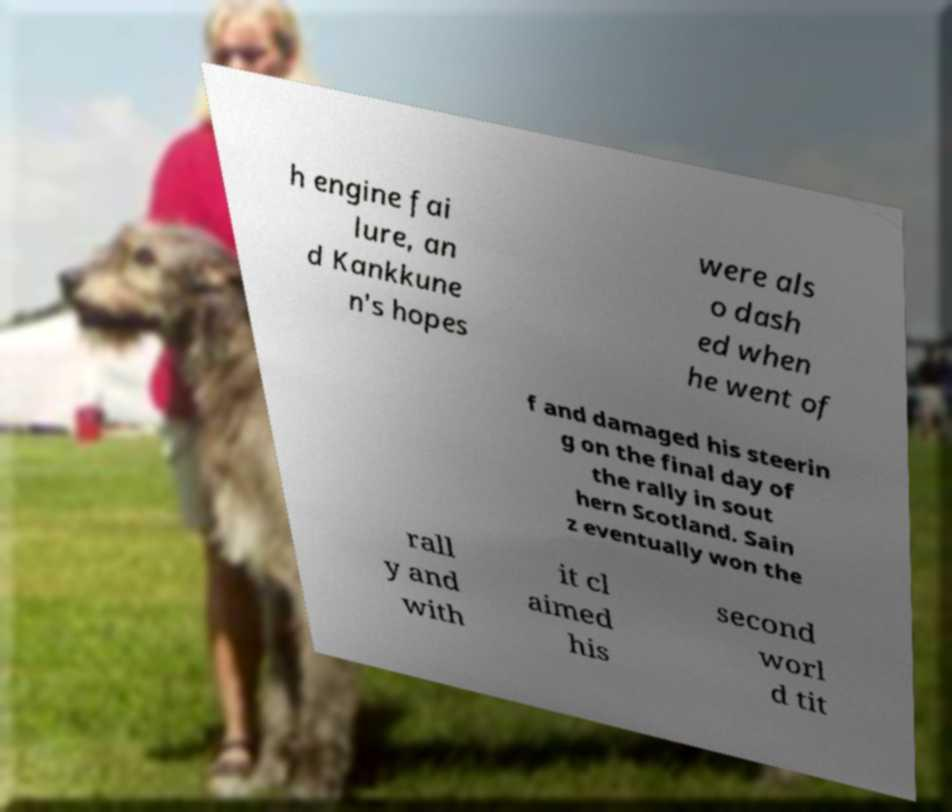Please identify and transcribe the text found in this image. h engine fai lure, an d Kankkune n's hopes were als o dash ed when he went of f and damaged his steerin g on the final day of the rally in sout hern Scotland. Sain z eventually won the rall y and with it cl aimed his second worl d tit 